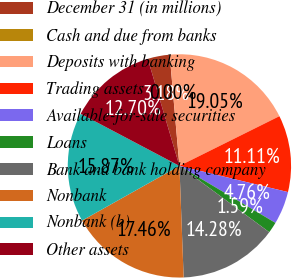Convert chart to OTSL. <chart><loc_0><loc_0><loc_500><loc_500><pie_chart><fcel>December 31 (in millions)<fcel>Cash and due from banks<fcel>Deposits with banking<fcel>Trading assets<fcel>Available-for-sale securities<fcel>Loans<fcel>Bank and bank holding company<fcel>Nonbank<fcel>Nonbank (b)<fcel>Other assets<nl><fcel>3.18%<fcel>0.0%<fcel>19.05%<fcel>11.11%<fcel>4.76%<fcel>1.59%<fcel>14.28%<fcel>17.46%<fcel>15.87%<fcel>12.7%<nl></chart> 